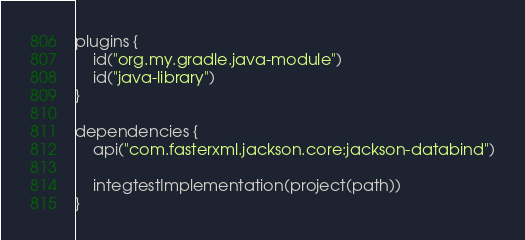<code> <loc_0><loc_0><loc_500><loc_500><_Kotlin_>plugins {
    id("org.my.gradle.java-module")
    id("java-library")
}

dependencies {
    api("com.fasterxml.jackson.core:jackson-databind")

    integtestImplementation(project(path))
}
</code> 